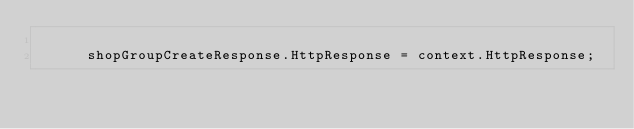Convert code to text. <code><loc_0><loc_0><loc_500><loc_500><_C#_>
			shopGroupCreateResponse.HttpResponse = context.HttpResponse;</code> 